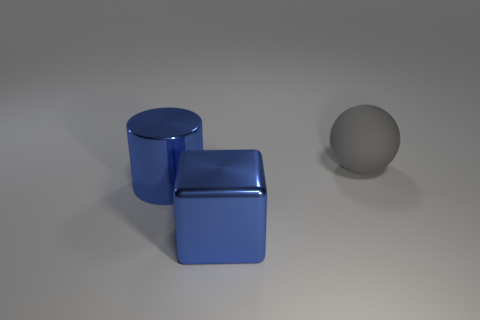What is the shape of the big shiny object that is right of the cylinder?
Offer a terse response. Cube. Do the large sphere and the big cylinder have the same color?
Give a very brief answer. No. Is there anything else that is the same shape as the big matte thing?
Your answer should be very brief. No. There is a large metal thing behind the large blue metallic cube; are there any blue metal things to the right of it?
Give a very brief answer. Yes. What number of other matte spheres have the same color as the ball?
Give a very brief answer. 0. What color is the large object that is behind the big object left of the shiny thing that is in front of the large blue cylinder?
Give a very brief answer. Gray. Are the large gray thing and the big cylinder made of the same material?
Give a very brief answer. No. Are there the same number of blue cylinders that are on the right side of the metallic cube and blue shiny blocks that are behind the big blue metallic cylinder?
Your answer should be compact. Yes. There is a large cylinder that is the same material as the block; what color is it?
Provide a short and direct response. Blue. What number of other large gray spheres are made of the same material as the gray ball?
Offer a terse response. 0. 